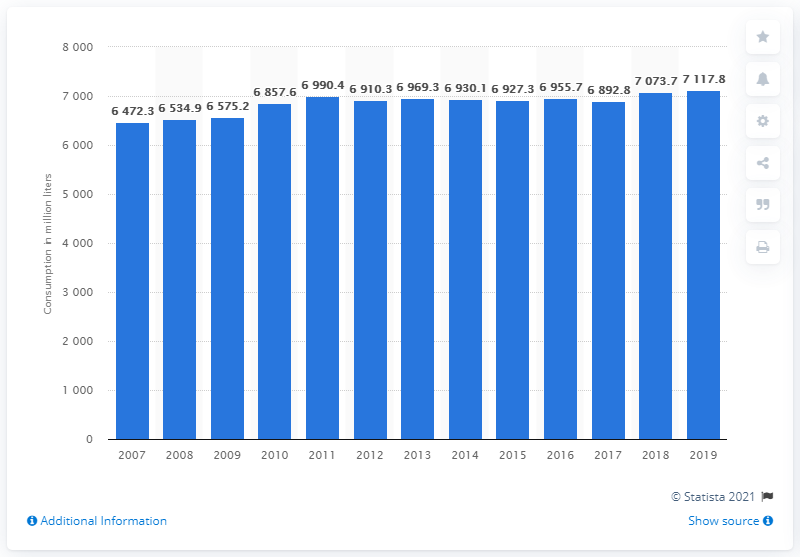Indicate a few pertinent items in this graphic. In 2019, the UK consumed a total of 7,117.8 liters of soft drinks. 